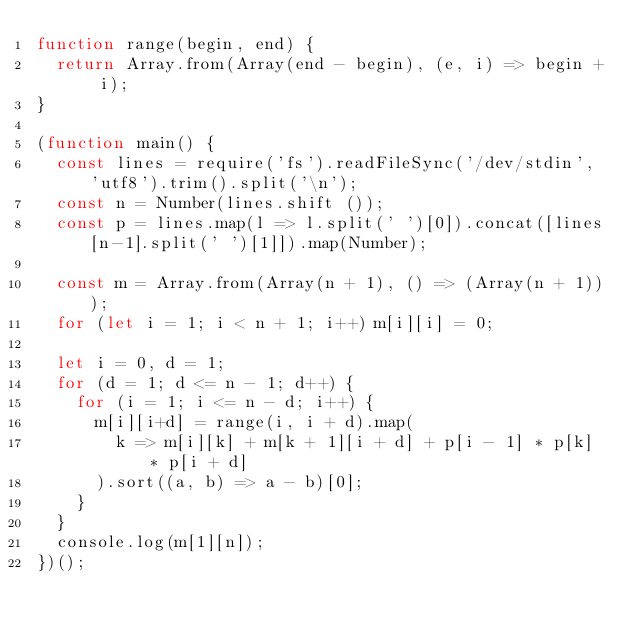Convert code to text. <code><loc_0><loc_0><loc_500><loc_500><_JavaScript_>function range(begin, end) {
  return Array.from(Array(end - begin), (e, i) => begin + i);
}

(function main() {
  const lines = require('fs').readFileSync('/dev/stdin', 'utf8').trim().split('\n');
  const n = Number(lines.shift ());
  const p = lines.map(l => l.split(' ')[0]).concat([lines[n-1].split(' ')[1]]).map(Number);

  const m = Array.from(Array(n + 1), () => (Array(n + 1)));
  for (let i = 1; i < n + 1; i++) m[i][i] = 0;

  let i = 0, d = 1;
  for (d = 1; d <= n - 1; d++) {
    for (i = 1; i <= n - d; i++) {
      m[i][i+d] = range(i, i + d).map(
        k => m[i][k] + m[k + 1][i + d] + p[i - 1] * p[k] * p[i + d]
      ).sort((a, b) => a - b)[0];
    }
  }
  console.log(m[1][n]);
})();

</code> 